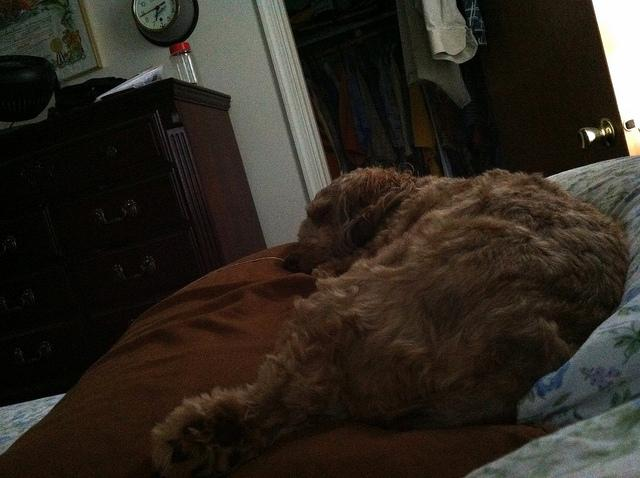What is on the bed? Please explain your reasoning. pet. The pet is on the bed. 